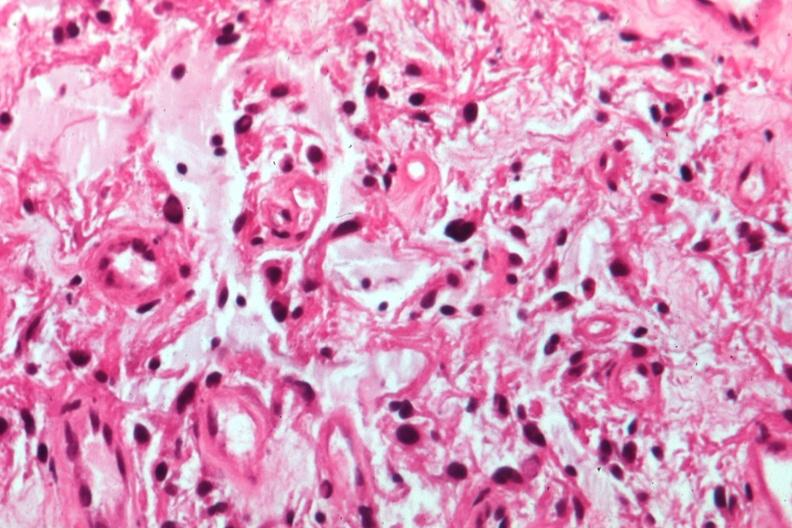does this image show glioma?
Answer the question using a single word or phrase. Yes 